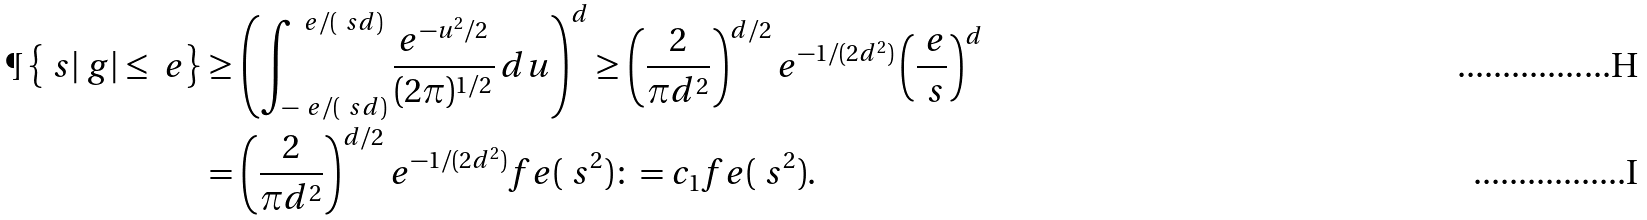<formula> <loc_0><loc_0><loc_500><loc_500>\P \left \{ \ s | \ g | \leq \ e \right \} & \geq \left ( \int _ { - \ e / ( \ s d ) } ^ { \ e / ( \ s d ) } \frac { e ^ { - u ^ { 2 } / 2 } } { ( 2 \pi ) ^ { 1 / 2 } } \, d u \right ) ^ { d } \geq \left ( \frac { 2 } { \pi d ^ { 2 } } \right ) ^ { d / 2 } e ^ { - 1 / ( 2 d ^ { 2 } ) } \left ( \frac { \ e } { \ s } \right ) ^ { d } \\ & = \left ( \frac { 2 } { \pi d ^ { 2 } } \right ) ^ { d / 2 } e ^ { - 1 / ( 2 d ^ { 2 } ) } f _ { \ } e ( \ s ^ { 2 } ) \colon = c _ { 1 } f _ { \ } e ( \ s ^ { 2 } ) .</formula> 